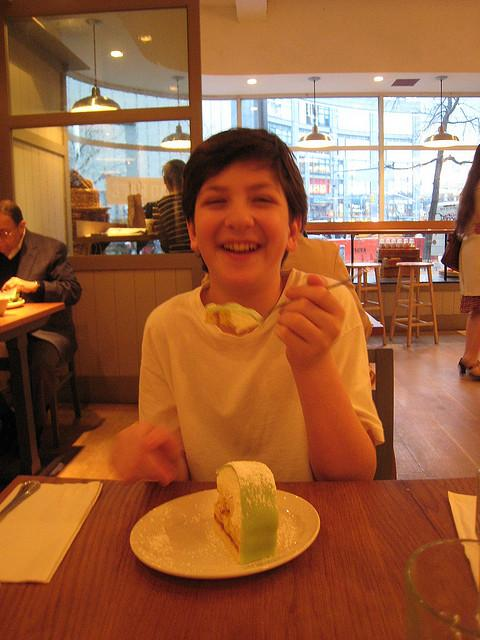What is this cake called? birthday cake 